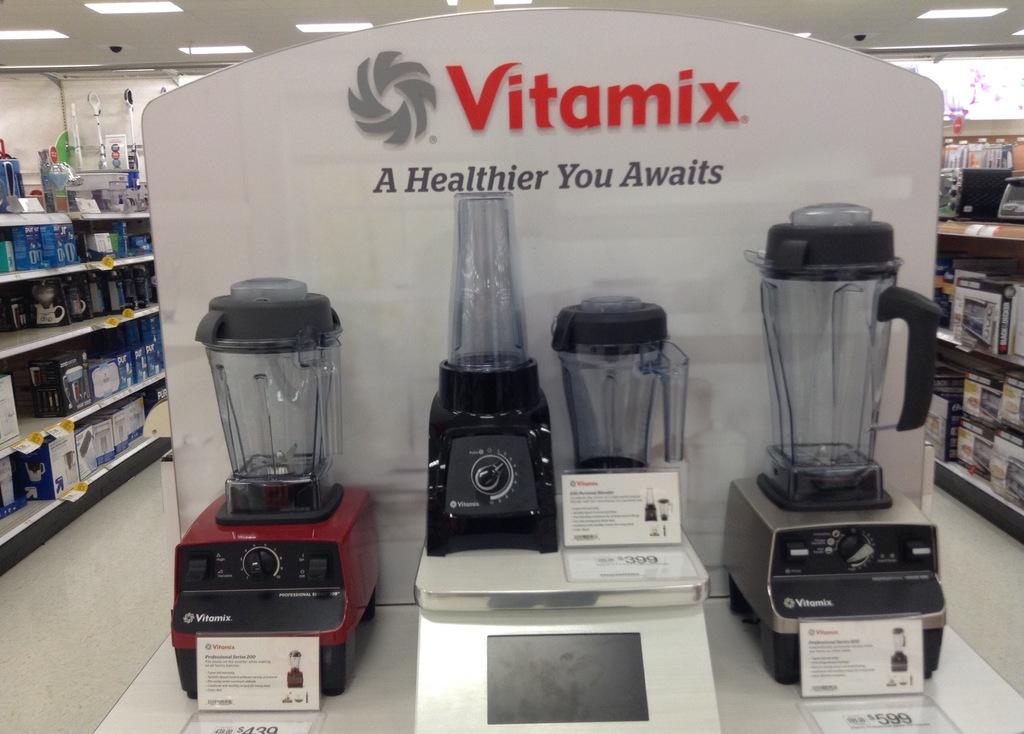What awaits if you use the blender?
Your response must be concise. A healthier you. What is the brand name of the blender?
Your response must be concise. Vitamix. 